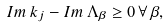<formula> <loc_0><loc_0><loc_500><loc_500>I m \, k _ { j } - I m \, \Lambda _ { \beta } \geq 0 \, \forall \, \beta ,</formula> 